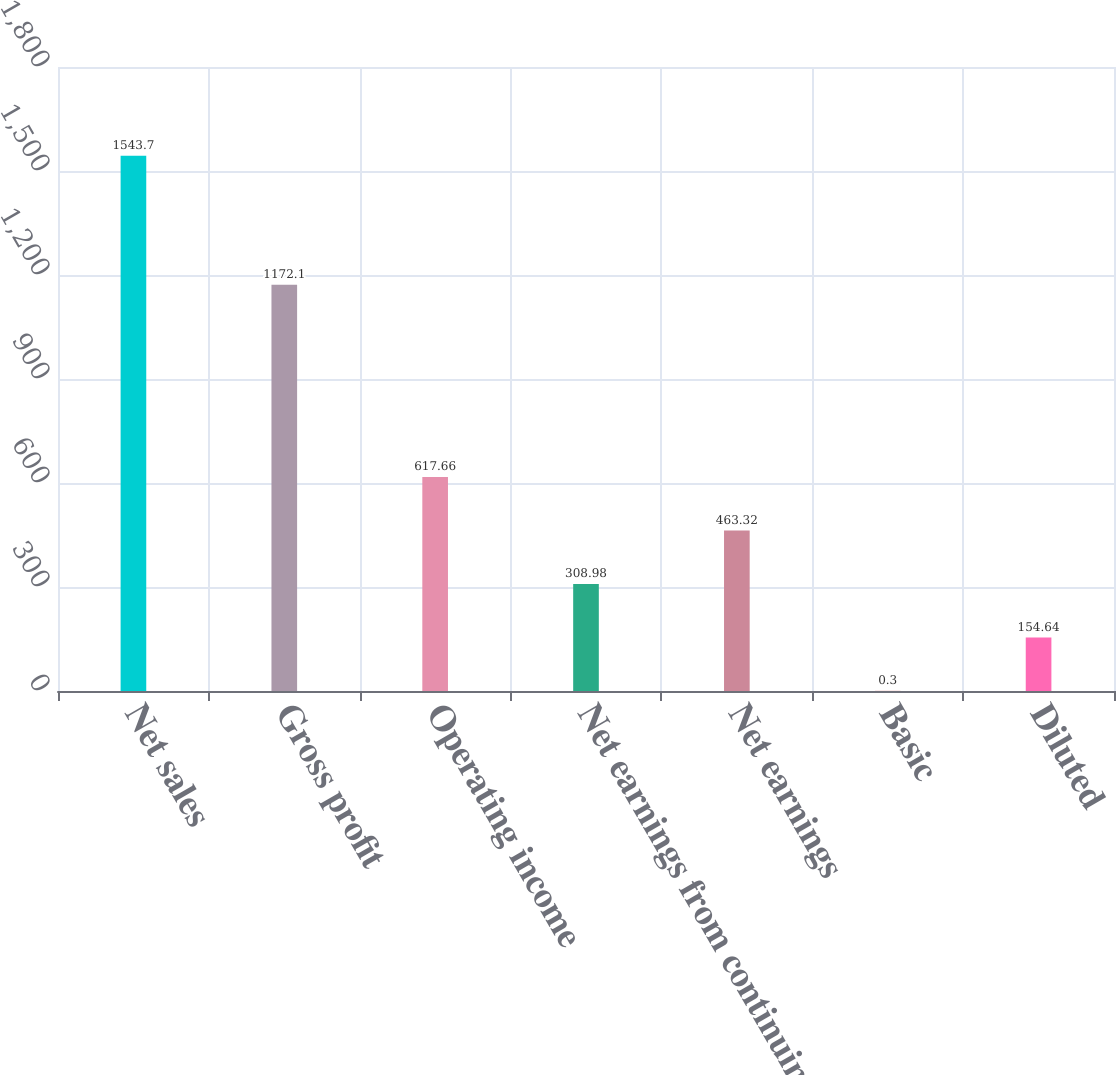Convert chart to OTSL. <chart><loc_0><loc_0><loc_500><loc_500><bar_chart><fcel>Net sales<fcel>Gross profit<fcel>Operating income<fcel>Net earnings from continuing<fcel>Net earnings<fcel>Basic<fcel>Diluted<nl><fcel>1543.7<fcel>1172.1<fcel>617.66<fcel>308.98<fcel>463.32<fcel>0.3<fcel>154.64<nl></chart> 